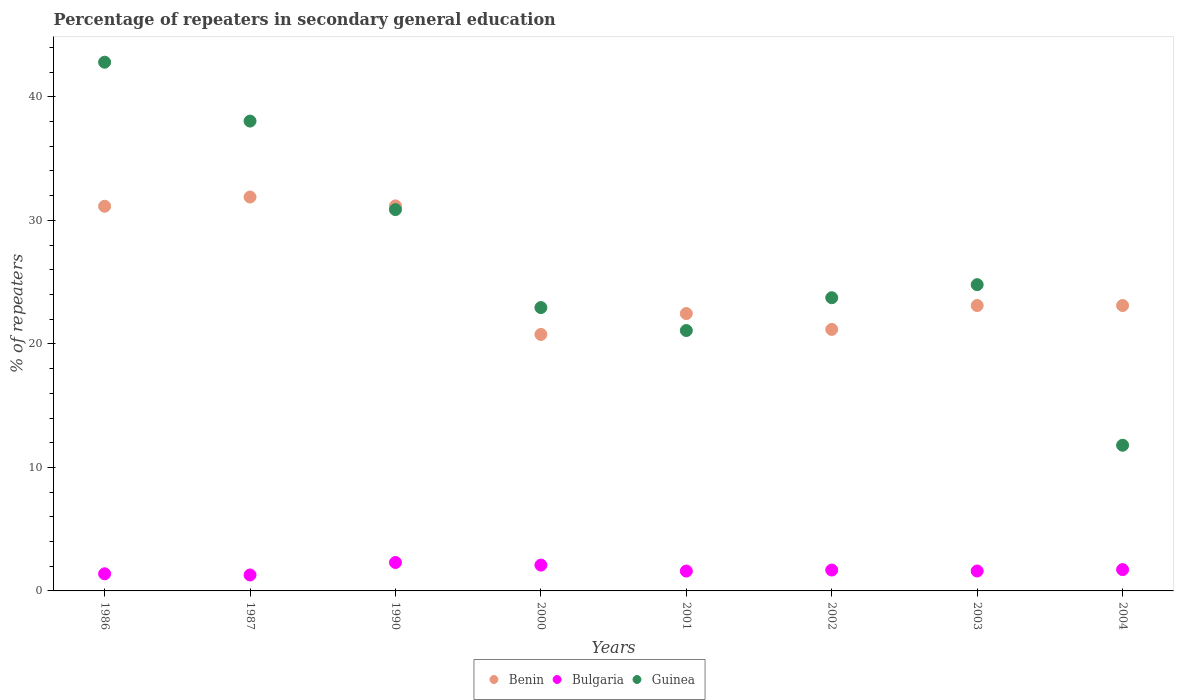How many different coloured dotlines are there?
Provide a succinct answer. 3. What is the percentage of repeaters in secondary general education in Guinea in 1987?
Make the answer very short. 38.04. Across all years, what is the maximum percentage of repeaters in secondary general education in Guinea?
Offer a terse response. 42.81. Across all years, what is the minimum percentage of repeaters in secondary general education in Guinea?
Provide a succinct answer. 11.79. In which year was the percentage of repeaters in secondary general education in Guinea maximum?
Ensure brevity in your answer.  1986. What is the total percentage of repeaters in secondary general education in Benin in the graph?
Your response must be concise. 204.82. What is the difference between the percentage of repeaters in secondary general education in Bulgaria in 1987 and that in 2001?
Provide a short and direct response. -0.32. What is the difference between the percentage of repeaters in secondary general education in Bulgaria in 1990 and the percentage of repeaters in secondary general education in Guinea in 1987?
Your answer should be compact. -35.74. What is the average percentage of repeaters in secondary general education in Benin per year?
Offer a terse response. 25.6. In the year 1986, what is the difference between the percentage of repeaters in secondary general education in Bulgaria and percentage of repeaters in secondary general education in Benin?
Your response must be concise. -29.76. What is the ratio of the percentage of repeaters in secondary general education in Guinea in 1986 to that in 2000?
Offer a terse response. 1.87. What is the difference between the highest and the second highest percentage of repeaters in secondary general education in Guinea?
Make the answer very short. 4.77. What is the difference between the highest and the lowest percentage of repeaters in secondary general education in Guinea?
Give a very brief answer. 31.01. In how many years, is the percentage of repeaters in secondary general education in Bulgaria greater than the average percentage of repeaters in secondary general education in Bulgaria taken over all years?
Your response must be concise. 3. Is it the case that in every year, the sum of the percentage of repeaters in secondary general education in Guinea and percentage of repeaters in secondary general education in Bulgaria  is greater than the percentage of repeaters in secondary general education in Benin?
Give a very brief answer. No. Does the percentage of repeaters in secondary general education in Guinea monotonically increase over the years?
Ensure brevity in your answer.  No. How many dotlines are there?
Your response must be concise. 3. What is the difference between two consecutive major ticks on the Y-axis?
Give a very brief answer. 10. Are the values on the major ticks of Y-axis written in scientific E-notation?
Make the answer very short. No. Does the graph contain any zero values?
Make the answer very short. No. Does the graph contain grids?
Offer a terse response. No. What is the title of the graph?
Keep it short and to the point. Percentage of repeaters in secondary general education. Does "Brunei Darussalam" appear as one of the legend labels in the graph?
Your answer should be compact. No. What is the label or title of the Y-axis?
Your answer should be very brief. % of repeaters. What is the % of repeaters of Benin in 1986?
Keep it short and to the point. 31.14. What is the % of repeaters of Bulgaria in 1986?
Your response must be concise. 1.39. What is the % of repeaters of Guinea in 1986?
Make the answer very short. 42.81. What is the % of repeaters in Benin in 1987?
Keep it short and to the point. 31.89. What is the % of repeaters in Bulgaria in 1987?
Offer a terse response. 1.29. What is the % of repeaters of Guinea in 1987?
Your answer should be compact. 38.04. What is the % of repeaters of Benin in 1990?
Your answer should be very brief. 31.17. What is the % of repeaters of Bulgaria in 1990?
Ensure brevity in your answer.  2.3. What is the % of repeaters in Guinea in 1990?
Provide a succinct answer. 30.87. What is the % of repeaters of Benin in 2000?
Offer a very short reply. 20.77. What is the % of repeaters of Bulgaria in 2000?
Give a very brief answer. 2.09. What is the % of repeaters of Guinea in 2000?
Your answer should be very brief. 22.94. What is the % of repeaters in Benin in 2001?
Make the answer very short. 22.46. What is the % of repeaters in Bulgaria in 2001?
Ensure brevity in your answer.  1.61. What is the % of repeaters in Guinea in 2001?
Your answer should be compact. 21.08. What is the % of repeaters of Benin in 2002?
Keep it short and to the point. 21.17. What is the % of repeaters of Bulgaria in 2002?
Provide a short and direct response. 1.69. What is the % of repeaters of Guinea in 2002?
Ensure brevity in your answer.  23.74. What is the % of repeaters in Benin in 2003?
Make the answer very short. 23.11. What is the % of repeaters of Bulgaria in 2003?
Ensure brevity in your answer.  1.61. What is the % of repeaters of Guinea in 2003?
Offer a very short reply. 24.8. What is the % of repeaters of Benin in 2004?
Provide a short and direct response. 23.11. What is the % of repeaters of Bulgaria in 2004?
Provide a short and direct response. 1.72. What is the % of repeaters in Guinea in 2004?
Offer a terse response. 11.79. Across all years, what is the maximum % of repeaters of Benin?
Your answer should be compact. 31.89. Across all years, what is the maximum % of repeaters of Bulgaria?
Provide a succinct answer. 2.3. Across all years, what is the maximum % of repeaters in Guinea?
Give a very brief answer. 42.81. Across all years, what is the minimum % of repeaters of Benin?
Your answer should be very brief. 20.77. Across all years, what is the minimum % of repeaters of Bulgaria?
Give a very brief answer. 1.29. Across all years, what is the minimum % of repeaters in Guinea?
Offer a very short reply. 11.79. What is the total % of repeaters of Benin in the graph?
Make the answer very short. 204.82. What is the total % of repeaters in Bulgaria in the graph?
Offer a very short reply. 13.7. What is the total % of repeaters of Guinea in the graph?
Offer a terse response. 216.07. What is the difference between the % of repeaters of Benin in 1986 and that in 1987?
Make the answer very short. -0.75. What is the difference between the % of repeaters of Bulgaria in 1986 and that in 1987?
Keep it short and to the point. 0.1. What is the difference between the % of repeaters of Guinea in 1986 and that in 1987?
Your answer should be very brief. 4.77. What is the difference between the % of repeaters of Benin in 1986 and that in 1990?
Offer a terse response. -0.03. What is the difference between the % of repeaters of Bulgaria in 1986 and that in 1990?
Ensure brevity in your answer.  -0.91. What is the difference between the % of repeaters in Guinea in 1986 and that in 1990?
Offer a terse response. 11.94. What is the difference between the % of repeaters of Benin in 1986 and that in 2000?
Your response must be concise. 10.38. What is the difference between the % of repeaters of Bulgaria in 1986 and that in 2000?
Keep it short and to the point. -0.7. What is the difference between the % of repeaters in Guinea in 1986 and that in 2000?
Offer a very short reply. 19.87. What is the difference between the % of repeaters of Benin in 1986 and that in 2001?
Your answer should be very brief. 8.69. What is the difference between the % of repeaters in Bulgaria in 1986 and that in 2001?
Ensure brevity in your answer.  -0.22. What is the difference between the % of repeaters of Guinea in 1986 and that in 2001?
Your response must be concise. 21.72. What is the difference between the % of repeaters in Benin in 1986 and that in 2002?
Your response must be concise. 9.97. What is the difference between the % of repeaters of Bulgaria in 1986 and that in 2002?
Your response must be concise. -0.3. What is the difference between the % of repeaters in Guinea in 1986 and that in 2002?
Offer a very short reply. 19.07. What is the difference between the % of repeaters of Benin in 1986 and that in 2003?
Your answer should be very brief. 8.04. What is the difference between the % of repeaters of Bulgaria in 1986 and that in 2003?
Make the answer very short. -0.23. What is the difference between the % of repeaters in Guinea in 1986 and that in 2003?
Ensure brevity in your answer.  18.01. What is the difference between the % of repeaters in Benin in 1986 and that in 2004?
Keep it short and to the point. 8.04. What is the difference between the % of repeaters of Bulgaria in 1986 and that in 2004?
Your response must be concise. -0.34. What is the difference between the % of repeaters in Guinea in 1986 and that in 2004?
Provide a succinct answer. 31.01. What is the difference between the % of repeaters in Benin in 1987 and that in 1990?
Your answer should be very brief. 0.72. What is the difference between the % of repeaters in Bulgaria in 1987 and that in 1990?
Give a very brief answer. -1.01. What is the difference between the % of repeaters of Guinea in 1987 and that in 1990?
Make the answer very short. 7.17. What is the difference between the % of repeaters of Benin in 1987 and that in 2000?
Your response must be concise. 11.13. What is the difference between the % of repeaters of Bulgaria in 1987 and that in 2000?
Make the answer very short. -0.8. What is the difference between the % of repeaters in Guinea in 1987 and that in 2000?
Make the answer very short. 15.1. What is the difference between the % of repeaters of Benin in 1987 and that in 2001?
Ensure brevity in your answer.  9.43. What is the difference between the % of repeaters in Bulgaria in 1987 and that in 2001?
Provide a succinct answer. -0.32. What is the difference between the % of repeaters in Guinea in 1987 and that in 2001?
Provide a short and direct response. 16.96. What is the difference between the % of repeaters of Benin in 1987 and that in 2002?
Your answer should be compact. 10.72. What is the difference between the % of repeaters of Bulgaria in 1987 and that in 2002?
Provide a short and direct response. -0.4. What is the difference between the % of repeaters in Guinea in 1987 and that in 2002?
Provide a succinct answer. 14.3. What is the difference between the % of repeaters in Benin in 1987 and that in 2003?
Make the answer very short. 8.78. What is the difference between the % of repeaters of Bulgaria in 1987 and that in 2003?
Your answer should be compact. -0.32. What is the difference between the % of repeaters in Guinea in 1987 and that in 2003?
Your response must be concise. 13.24. What is the difference between the % of repeaters of Benin in 1987 and that in 2004?
Offer a very short reply. 8.78. What is the difference between the % of repeaters of Bulgaria in 1987 and that in 2004?
Give a very brief answer. -0.43. What is the difference between the % of repeaters in Guinea in 1987 and that in 2004?
Ensure brevity in your answer.  26.25. What is the difference between the % of repeaters in Benin in 1990 and that in 2000?
Give a very brief answer. 10.41. What is the difference between the % of repeaters of Bulgaria in 1990 and that in 2000?
Your response must be concise. 0.21. What is the difference between the % of repeaters in Guinea in 1990 and that in 2000?
Your answer should be compact. 7.93. What is the difference between the % of repeaters of Benin in 1990 and that in 2001?
Offer a very short reply. 8.72. What is the difference between the % of repeaters of Bulgaria in 1990 and that in 2001?
Offer a very short reply. 0.69. What is the difference between the % of repeaters of Guinea in 1990 and that in 2001?
Ensure brevity in your answer.  9.79. What is the difference between the % of repeaters in Benin in 1990 and that in 2002?
Provide a short and direct response. 10. What is the difference between the % of repeaters of Bulgaria in 1990 and that in 2002?
Give a very brief answer. 0.61. What is the difference between the % of repeaters of Guinea in 1990 and that in 2002?
Make the answer very short. 7.13. What is the difference between the % of repeaters in Benin in 1990 and that in 2003?
Provide a short and direct response. 8.07. What is the difference between the % of repeaters of Bulgaria in 1990 and that in 2003?
Give a very brief answer. 0.69. What is the difference between the % of repeaters in Guinea in 1990 and that in 2003?
Your answer should be compact. 6.08. What is the difference between the % of repeaters in Benin in 1990 and that in 2004?
Offer a terse response. 8.07. What is the difference between the % of repeaters of Bulgaria in 1990 and that in 2004?
Offer a very short reply. 0.58. What is the difference between the % of repeaters of Guinea in 1990 and that in 2004?
Ensure brevity in your answer.  19.08. What is the difference between the % of repeaters of Benin in 2000 and that in 2001?
Ensure brevity in your answer.  -1.69. What is the difference between the % of repeaters in Bulgaria in 2000 and that in 2001?
Your answer should be very brief. 0.48. What is the difference between the % of repeaters in Guinea in 2000 and that in 2001?
Ensure brevity in your answer.  1.86. What is the difference between the % of repeaters of Benin in 2000 and that in 2002?
Provide a succinct answer. -0.41. What is the difference between the % of repeaters of Bulgaria in 2000 and that in 2002?
Offer a terse response. 0.4. What is the difference between the % of repeaters of Guinea in 2000 and that in 2002?
Ensure brevity in your answer.  -0.8. What is the difference between the % of repeaters of Benin in 2000 and that in 2003?
Provide a short and direct response. -2.34. What is the difference between the % of repeaters of Bulgaria in 2000 and that in 2003?
Your response must be concise. 0.48. What is the difference between the % of repeaters in Guinea in 2000 and that in 2003?
Your answer should be very brief. -1.85. What is the difference between the % of repeaters in Benin in 2000 and that in 2004?
Provide a short and direct response. -2.34. What is the difference between the % of repeaters in Bulgaria in 2000 and that in 2004?
Offer a terse response. 0.37. What is the difference between the % of repeaters in Guinea in 2000 and that in 2004?
Give a very brief answer. 11.15. What is the difference between the % of repeaters in Benin in 2001 and that in 2002?
Offer a terse response. 1.29. What is the difference between the % of repeaters of Bulgaria in 2001 and that in 2002?
Make the answer very short. -0.08. What is the difference between the % of repeaters of Guinea in 2001 and that in 2002?
Provide a short and direct response. -2.66. What is the difference between the % of repeaters in Benin in 2001 and that in 2003?
Offer a very short reply. -0.65. What is the difference between the % of repeaters of Bulgaria in 2001 and that in 2003?
Provide a short and direct response. -0. What is the difference between the % of repeaters of Guinea in 2001 and that in 2003?
Give a very brief answer. -3.71. What is the difference between the % of repeaters of Benin in 2001 and that in 2004?
Offer a very short reply. -0.65. What is the difference between the % of repeaters of Bulgaria in 2001 and that in 2004?
Give a very brief answer. -0.12. What is the difference between the % of repeaters in Guinea in 2001 and that in 2004?
Your response must be concise. 9.29. What is the difference between the % of repeaters in Benin in 2002 and that in 2003?
Your response must be concise. -1.94. What is the difference between the % of repeaters of Bulgaria in 2002 and that in 2003?
Provide a succinct answer. 0.08. What is the difference between the % of repeaters of Guinea in 2002 and that in 2003?
Offer a very short reply. -1.06. What is the difference between the % of repeaters of Benin in 2002 and that in 2004?
Make the answer very short. -1.94. What is the difference between the % of repeaters of Bulgaria in 2002 and that in 2004?
Provide a short and direct response. -0.03. What is the difference between the % of repeaters of Guinea in 2002 and that in 2004?
Keep it short and to the point. 11.94. What is the difference between the % of repeaters of Benin in 2003 and that in 2004?
Offer a terse response. -0. What is the difference between the % of repeaters of Bulgaria in 2003 and that in 2004?
Offer a very short reply. -0.11. What is the difference between the % of repeaters of Guinea in 2003 and that in 2004?
Make the answer very short. 13. What is the difference between the % of repeaters of Benin in 1986 and the % of repeaters of Bulgaria in 1987?
Provide a succinct answer. 29.85. What is the difference between the % of repeaters in Benin in 1986 and the % of repeaters in Guinea in 1987?
Offer a very short reply. -6.9. What is the difference between the % of repeaters in Bulgaria in 1986 and the % of repeaters in Guinea in 1987?
Offer a terse response. -36.65. What is the difference between the % of repeaters of Benin in 1986 and the % of repeaters of Bulgaria in 1990?
Your answer should be compact. 28.84. What is the difference between the % of repeaters in Benin in 1986 and the % of repeaters in Guinea in 1990?
Offer a very short reply. 0.27. What is the difference between the % of repeaters in Bulgaria in 1986 and the % of repeaters in Guinea in 1990?
Your answer should be very brief. -29.48. What is the difference between the % of repeaters of Benin in 1986 and the % of repeaters of Bulgaria in 2000?
Your answer should be very brief. 29.05. What is the difference between the % of repeaters of Benin in 1986 and the % of repeaters of Guinea in 2000?
Provide a succinct answer. 8.2. What is the difference between the % of repeaters of Bulgaria in 1986 and the % of repeaters of Guinea in 2000?
Give a very brief answer. -21.55. What is the difference between the % of repeaters in Benin in 1986 and the % of repeaters in Bulgaria in 2001?
Make the answer very short. 29.54. What is the difference between the % of repeaters in Benin in 1986 and the % of repeaters in Guinea in 2001?
Offer a very short reply. 10.06. What is the difference between the % of repeaters in Bulgaria in 1986 and the % of repeaters in Guinea in 2001?
Your response must be concise. -19.7. What is the difference between the % of repeaters in Benin in 1986 and the % of repeaters in Bulgaria in 2002?
Keep it short and to the point. 29.45. What is the difference between the % of repeaters of Benin in 1986 and the % of repeaters of Guinea in 2002?
Make the answer very short. 7.4. What is the difference between the % of repeaters of Bulgaria in 1986 and the % of repeaters of Guinea in 2002?
Your response must be concise. -22.35. What is the difference between the % of repeaters in Benin in 1986 and the % of repeaters in Bulgaria in 2003?
Your response must be concise. 29.53. What is the difference between the % of repeaters of Benin in 1986 and the % of repeaters of Guinea in 2003?
Provide a short and direct response. 6.35. What is the difference between the % of repeaters in Bulgaria in 1986 and the % of repeaters in Guinea in 2003?
Your response must be concise. -23.41. What is the difference between the % of repeaters in Benin in 1986 and the % of repeaters in Bulgaria in 2004?
Your answer should be very brief. 29.42. What is the difference between the % of repeaters in Benin in 1986 and the % of repeaters in Guinea in 2004?
Offer a terse response. 19.35. What is the difference between the % of repeaters of Bulgaria in 1986 and the % of repeaters of Guinea in 2004?
Make the answer very short. -10.41. What is the difference between the % of repeaters of Benin in 1987 and the % of repeaters of Bulgaria in 1990?
Provide a short and direct response. 29.59. What is the difference between the % of repeaters of Benin in 1987 and the % of repeaters of Guinea in 1990?
Keep it short and to the point. 1.02. What is the difference between the % of repeaters of Bulgaria in 1987 and the % of repeaters of Guinea in 1990?
Your answer should be compact. -29.58. What is the difference between the % of repeaters of Benin in 1987 and the % of repeaters of Bulgaria in 2000?
Your answer should be compact. 29.8. What is the difference between the % of repeaters of Benin in 1987 and the % of repeaters of Guinea in 2000?
Ensure brevity in your answer.  8.95. What is the difference between the % of repeaters in Bulgaria in 1987 and the % of repeaters in Guinea in 2000?
Provide a short and direct response. -21.65. What is the difference between the % of repeaters in Benin in 1987 and the % of repeaters in Bulgaria in 2001?
Your response must be concise. 30.28. What is the difference between the % of repeaters of Benin in 1987 and the % of repeaters of Guinea in 2001?
Provide a succinct answer. 10.81. What is the difference between the % of repeaters of Bulgaria in 1987 and the % of repeaters of Guinea in 2001?
Offer a terse response. -19.79. What is the difference between the % of repeaters in Benin in 1987 and the % of repeaters in Bulgaria in 2002?
Your answer should be compact. 30.2. What is the difference between the % of repeaters of Benin in 1987 and the % of repeaters of Guinea in 2002?
Your response must be concise. 8.15. What is the difference between the % of repeaters in Bulgaria in 1987 and the % of repeaters in Guinea in 2002?
Your response must be concise. -22.45. What is the difference between the % of repeaters in Benin in 1987 and the % of repeaters in Bulgaria in 2003?
Ensure brevity in your answer.  30.28. What is the difference between the % of repeaters in Benin in 1987 and the % of repeaters in Guinea in 2003?
Make the answer very short. 7.1. What is the difference between the % of repeaters in Bulgaria in 1987 and the % of repeaters in Guinea in 2003?
Make the answer very short. -23.51. What is the difference between the % of repeaters of Benin in 1987 and the % of repeaters of Bulgaria in 2004?
Your answer should be very brief. 30.17. What is the difference between the % of repeaters in Benin in 1987 and the % of repeaters in Guinea in 2004?
Your response must be concise. 20.1. What is the difference between the % of repeaters of Bulgaria in 1987 and the % of repeaters of Guinea in 2004?
Offer a terse response. -10.5. What is the difference between the % of repeaters in Benin in 1990 and the % of repeaters in Bulgaria in 2000?
Give a very brief answer. 29.08. What is the difference between the % of repeaters of Benin in 1990 and the % of repeaters of Guinea in 2000?
Your answer should be very brief. 8.23. What is the difference between the % of repeaters in Bulgaria in 1990 and the % of repeaters in Guinea in 2000?
Offer a terse response. -20.64. What is the difference between the % of repeaters in Benin in 1990 and the % of repeaters in Bulgaria in 2001?
Provide a short and direct response. 29.57. What is the difference between the % of repeaters of Benin in 1990 and the % of repeaters of Guinea in 2001?
Ensure brevity in your answer.  10.09. What is the difference between the % of repeaters in Bulgaria in 1990 and the % of repeaters in Guinea in 2001?
Give a very brief answer. -18.78. What is the difference between the % of repeaters in Benin in 1990 and the % of repeaters in Bulgaria in 2002?
Your response must be concise. 29.48. What is the difference between the % of repeaters in Benin in 1990 and the % of repeaters in Guinea in 2002?
Your answer should be compact. 7.44. What is the difference between the % of repeaters of Bulgaria in 1990 and the % of repeaters of Guinea in 2002?
Keep it short and to the point. -21.44. What is the difference between the % of repeaters of Benin in 1990 and the % of repeaters of Bulgaria in 2003?
Give a very brief answer. 29.56. What is the difference between the % of repeaters in Benin in 1990 and the % of repeaters in Guinea in 2003?
Provide a succinct answer. 6.38. What is the difference between the % of repeaters of Bulgaria in 1990 and the % of repeaters of Guinea in 2003?
Your answer should be very brief. -22.5. What is the difference between the % of repeaters in Benin in 1990 and the % of repeaters in Bulgaria in 2004?
Your response must be concise. 29.45. What is the difference between the % of repeaters of Benin in 1990 and the % of repeaters of Guinea in 2004?
Provide a succinct answer. 19.38. What is the difference between the % of repeaters in Bulgaria in 1990 and the % of repeaters in Guinea in 2004?
Give a very brief answer. -9.49. What is the difference between the % of repeaters in Benin in 2000 and the % of repeaters in Bulgaria in 2001?
Provide a short and direct response. 19.16. What is the difference between the % of repeaters in Benin in 2000 and the % of repeaters in Guinea in 2001?
Make the answer very short. -0.32. What is the difference between the % of repeaters of Bulgaria in 2000 and the % of repeaters of Guinea in 2001?
Your answer should be very brief. -18.99. What is the difference between the % of repeaters of Benin in 2000 and the % of repeaters of Bulgaria in 2002?
Make the answer very short. 19.08. What is the difference between the % of repeaters in Benin in 2000 and the % of repeaters in Guinea in 2002?
Provide a short and direct response. -2.97. What is the difference between the % of repeaters of Bulgaria in 2000 and the % of repeaters of Guinea in 2002?
Offer a terse response. -21.65. What is the difference between the % of repeaters of Benin in 2000 and the % of repeaters of Bulgaria in 2003?
Give a very brief answer. 19.15. What is the difference between the % of repeaters in Benin in 2000 and the % of repeaters in Guinea in 2003?
Keep it short and to the point. -4.03. What is the difference between the % of repeaters in Bulgaria in 2000 and the % of repeaters in Guinea in 2003?
Offer a very short reply. -22.71. What is the difference between the % of repeaters of Benin in 2000 and the % of repeaters of Bulgaria in 2004?
Give a very brief answer. 19.04. What is the difference between the % of repeaters in Benin in 2000 and the % of repeaters in Guinea in 2004?
Provide a succinct answer. 8.97. What is the difference between the % of repeaters in Bulgaria in 2000 and the % of repeaters in Guinea in 2004?
Your answer should be compact. -9.7. What is the difference between the % of repeaters of Benin in 2001 and the % of repeaters of Bulgaria in 2002?
Provide a short and direct response. 20.77. What is the difference between the % of repeaters in Benin in 2001 and the % of repeaters in Guinea in 2002?
Make the answer very short. -1.28. What is the difference between the % of repeaters of Bulgaria in 2001 and the % of repeaters of Guinea in 2002?
Your answer should be compact. -22.13. What is the difference between the % of repeaters of Benin in 2001 and the % of repeaters of Bulgaria in 2003?
Your answer should be very brief. 20.84. What is the difference between the % of repeaters in Benin in 2001 and the % of repeaters in Guinea in 2003?
Give a very brief answer. -2.34. What is the difference between the % of repeaters of Bulgaria in 2001 and the % of repeaters of Guinea in 2003?
Keep it short and to the point. -23.19. What is the difference between the % of repeaters of Benin in 2001 and the % of repeaters of Bulgaria in 2004?
Give a very brief answer. 20.73. What is the difference between the % of repeaters in Benin in 2001 and the % of repeaters in Guinea in 2004?
Give a very brief answer. 10.66. What is the difference between the % of repeaters in Bulgaria in 2001 and the % of repeaters in Guinea in 2004?
Give a very brief answer. -10.19. What is the difference between the % of repeaters of Benin in 2002 and the % of repeaters of Bulgaria in 2003?
Your answer should be very brief. 19.56. What is the difference between the % of repeaters in Benin in 2002 and the % of repeaters in Guinea in 2003?
Keep it short and to the point. -3.62. What is the difference between the % of repeaters in Bulgaria in 2002 and the % of repeaters in Guinea in 2003?
Keep it short and to the point. -23.11. What is the difference between the % of repeaters in Benin in 2002 and the % of repeaters in Bulgaria in 2004?
Offer a very short reply. 19.45. What is the difference between the % of repeaters of Benin in 2002 and the % of repeaters of Guinea in 2004?
Your answer should be compact. 9.38. What is the difference between the % of repeaters of Bulgaria in 2002 and the % of repeaters of Guinea in 2004?
Your answer should be very brief. -10.1. What is the difference between the % of repeaters in Benin in 2003 and the % of repeaters in Bulgaria in 2004?
Keep it short and to the point. 21.38. What is the difference between the % of repeaters of Benin in 2003 and the % of repeaters of Guinea in 2004?
Make the answer very short. 11.31. What is the difference between the % of repeaters in Bulgaria in 2003 and the % of repeaters in Guinea in 2004?
Your answer should be compact. -10.18. What is the average % of repeaters of Benin per year?
Offer a terse response. 25.6. What is the average % of repeaters in Bulgaria per year?
Offer a very short reply. 1.71. What is the average % of repeaters in Guinea per year?
Provide a short and direct response. 27.01. In the year 1986, what is the difference between the % of repeaters in Benin and % of repeaters in Bulgaria?
Give a very brief answer. 29.76. In the year 1986, what is the difference between the % of repeaters of Benin and % of repeaters of Guinea?
Make the answer very short. -11.66. In the year 1986, what is the difference between the % of repeaters of Bulgaria and % of repeaters of Guinea?
Offer a terse response. -41.42. In the year 1987, what is the difference between the % of repeaters in Benin and % of repeaters in Bulgaria?
Offer a terse response. 30.6. In the year 1987, what is the difference between the % of repeaters in Benin and % of repeaters in Guinea?
Ensure brevity in your answer.  -6.15. In the year 1987, what is the difference between the % of repeaters of Bulgaria and % of repeaters of Guinea?
Offer a terse response. -36.75. In the year 1990, what is the difference between the % of repeaters in Benin and % of repeaters in Bulgaria?
Your answer should be very brief. 28.87. In the year 1990, what is the difference between the % of repeaters of Benin and % of repeaters of Guinea?
Provide a succinct answer. 0.3. In the year 1990, what is the difference between the % of repeaters of Bulgaria and % of repeaters of Guinea?
Give a very brief answer. -28.57. In the year 2000, what is the difference between the % of repeaters in Benin and % of repeaters in Bulgaria?
Keep it short and to the point. 18.68. In the year 2000, what is the difference between the % of repeaters of Benin and % of repeaters of Guinea?
Your response must be concise. -2.18. In the year 2000, what is the difference between the % of repeaters in Bulgaria and % of repeaters in Guinea?
Provide a short and direct response. -20.85. In the year 2001, what is the difference between the % of repeaters of Benin and % of repeaters of Bulgaria?
Give a very brief answer. 20.85. In the year 2001, what is the difference between the % of repeaters in Benin and % of repeaters in Guinea?
Ensure brevity in your answer.  1.37. In the year 2001, what is the difference between the % of repeaters of Bulgaria and % of repeaters of Guinea?
Provide a short and direct response. -19.48. In the year 2002, what is the difference between the % of repeaters in Benin and % of repeaters in Bulgaria?
Your answer should be very brief. 19.48. In the year 2002, what is the difference between the % of repeaters in Benin and % of repeaters in Guinea?
Keep it short and to the point. -2.57. In the year 2002, what is the difference between the % of repeaters of Bulgaria and % of repeaters of Guinea?
Give a very brief answer. -22.05. In the year 2003, what is the difference between the % of repeaters in Benin and % of repeaters in Bulgaria?
Your response must be concise. 21.5. In the year 2003, what is the difference between the % of repeaters of Benin and % of repeaters of Guinea?
Your answer should be very brief. -1.69. In the year 2003, what is the difference between the % of repeaters of Bulgaria and % of repeaters of Guinea?
Ensure brevity in your answer.  -23.18. In the year 2004, what is the difference between the % of repeaters of Benin and % of repeaters of Bulgaria?
Make the answer very short. 21.38. In the year 2004, what is the difference between the % of repeaters in Benin and % of repeaters in Guinea?
Make the answer very short. 11.31. In the year 2004, what is the difference between the % of repeaters in Bulgaria and % of repeaters in Guinea?
Give a very brief answer. -10.07. What is the ratio of the % of repeaters in Benin in 1986 to that in 1987?
Your answer should be compact. 0.98. What is the ratio of the % of repeaters in Bulgaria in 1986 to that in 1987?
Keep it short and to the point. 1.07. What is the ratio of the % of repeaters of Guinea in 1986 to that in 1987?
Your answer should be compact. 1.13. What is the ratio of the % of repeaters in Bulgaria in 1986 to that in 1990?
Your answer should be compact. 0.6. What is the ratio of the % of repeaters of Guinea in 1986 to that in 1990?
Your answer should be very brief. 1.39. What is the ratio of the % of repeaters in Benin in 1986 to that in 2000?
Your response must be concise. 1.5. What is the ratio of the % of repeaters in Bulgaria in 1986 to that in 2000?
Ensure brevity in your answer.  0.66. What is the ratio of the % of repeaters in Guinea in 1986 to that in 2000?
Offer a very short reply. 1.87. What is the ratio of the % of repeaters of Benin in 1986 to that in 2001?
Make the answer very short. 1.39. What is the ratio of the % of repeaters in Bulgaria in 1986 to that in 2001?
Provide a short and direct response. 0.86. What is the ratio of the % of repeaters in Guinea in 1986 to that in 2001?
Your answer should be compact. 2.03. What is the ratio of the % of repeaters of Benin in 1986 to that in 2002?
Offer a terse response. 1.47. What is the ratio of the % of repeaters of Bulgaria in 1986 to that in 2002?
Your response must be concise. 0.82. What is the ratio of the % of repeaters in Guinea in 1986 to that in 2002?
Offer a terse response. 1.8. What is the ratio of the % of repeaters in Benin in 1986 to that in 2003?
Your response must be concise. 1.35. What is the ratio of the % of repeaters in Bulgaria in 1986 to that in 2003?
Your answer should be compact. 0.86. What is the ratio of the % of repeaters of Guinea in 1986 to that in 2003?
Your answer should be compact. 1.73. What is the ratio of the % of repeaters of Benin in 1986 to that in 2004?
Offer a terse response. 1.35. What is the ratio of the % of repeaters of Bulgaria in 1986 to that in 2004?
Make the answer very short. 0.8. What is the ratio of the % of repeaters of Guinea in 1986 to that in 2004?
Keep it short and to the point. 3.63. What is the ratio of the % of repeaters in Benin in 1987 to that in 1990?
Give a very brief answer. 1.02. What is the ratio of the % of repeaters of Bulgaria in 1987 to that in 1990?
Provide a succinct answer. 0.56. What is the ratio of the % of repeaters in Guinea in 1987 to that in 1990?
Your answer should be very brief. 1.23. What is the ratio of the % of repeaters in Benin in 1987 to that in 2000?
Make the answer very short. 1.54. What is the ratio of the % of repeaters of Bulgaria in 1987 to that in 2000?
Make the answer very short. 0.62. What is the ratio of the % of repeaters in Guinea in 1987 to that in 2000?
Keep it short and to the point. 1.66. What is the ratio of the % of repeaters of Benin in 1987 to that in 2001?
Keep it short and to the point. 1.42. What is the ratio of the % of repeaters in Bulgaria in 1987 to that in 2001?
Give a very brief answer. 0.8. What is the ratio of the % of repeaters in Guinea in 1987 to that in 2001?
Give a very brief answer. 1.8. What is the ratio of the % of repeaters of Benin in 1987 to that in 2002?
Offer a terse response. 1.51. What is the ratio of the % of repeaters of Bulgaria in 1987 to that in 2002?
Ensure brevity in your answer.  0.76. What is the ratio of the % of repeaters of Guinea in 1987 to that in 2002?
Make the answer very short. 1.6. What is the ratio of the % of repeaters of Benin in 1987 to that in 2003?
Keep it short and to the point. 1.38. What is the ratio of the % of repeaters of Bulgaria in 1987 to that in 2003?
Keep it short and to the point. 0.8. What is the ratio of the % of repeaters in Guinea in 1987 to that in 2003?
Your answer should be compact. 1.53. What is the ratio of the % of repeaters in Benin in 1987 to that in 2004?
Your response must be concise. 1.38. What is the ratio of the % of repeaters in Bulgaria in 1987 to that in 2004?
Offer a very short reply. 0.75. What is the ratio of the % of repeaters in Guinea in 1987 to that in 2004?
Make the answer very short. 3.23. What is the ratio of the % of repeaters of Benin in 1990 to that in 2000?
Make the answer very short. 1.5. What is the ratio of the % of repeaters of Bulgaria in 1990 to that in 2000?
Make the answer very short. 1.1. What is the ratio of the % of repeaters of Guinea in 1990 to that in 2000?
Give a very brief answer. 1.35. What is the ratio of the % of repeaters in Benin in 1990 to that in 2001?
Keep it short and to the point. 1.39. What is the ratio of the % of repeaters in Bulgaria in 1990 to that in 2001?
Provide a short and direct response. 1.43. What is the ratio of the % of repeaters of Guinea in 1990 to that in 2001?
Your answer should be compact. 1.46. What is the ratio of the % of repeaters in Benin in 1990 to that in 2002?
Make the answer very short. 1.47. What is the ratio of the % of repeaters of Bulgaria in 1990 to that in 2002?
Give a very brief answer. 1.36. What is the ratio of the % of repeaters of Guinea in 1990 to that in 2002?
Provide a succinct answer. 1.3. What is the ratio of the % of repeaters of Benin in 1990 to that in 2003?
Your answer should be very brief. 1.35. What is the ratio of the % of repeaters of Bulgaria in 1990 to that in 2003?
Your answer should be very brief. 1.43. What is the ratio of the % of repeaters in Guinea in 1990 to that in 2003?
Your response must be concise. 1.25. What is the ratio of the % of repeaters of Benin in 1990 to that in 2004?
Provide a short and direct response. 1.35. What is the ratio of the % of repeaters in Bulgaria in 1990 to that in 2004?
Give a very brief answer. 1.33. What is the ratio of the % of repeaters in Guinea in 1990 to that in 2004?
Provide a succinct answer. 2.62. What is the ratio of the % of repeaters of Benin in 2000 to that in 2001?
Offer a terse response. 0.92. What is the ratio of the % of repeaters in Bulgaria in 2000 to that in 2001?
Give a very brief answer. 1.3. What is the ratio of the % of repeaters in Guinea in 2000 to that in 2001?
Ensure brevity in your answer.  1.09. What is the ratio of the % of repeaters of Benin in 2000 to that in 2002?
Offer a terse response. 0.98. What is the ratio of the % of repeaters in Bulgaria in 2000 to that in 2002?
Your answer should be compact. 1.24. What is the ratio of the % of repeaters in Guinea in 2000 to that in 2002?
Your response must be concise. 0.97. What is the ratio of the % of repeaters of Benin in 2000 to that in 2003?
Offer a terse response. 0.9. What is the ratio of the % of repeaters in Bulgaria in 2000 to that in 2003?
Give a very brief answer. 1.3. What is the ratio of the % of repeaters in Guinea in 2000 to that in 2003?
Your answer should be compact. 0.93. What is the ratio of the % of repeaters in Benin in 2000 to that in 2004?
Offer a terse response. 0.9. What is the ratio of the % of repeaters of Bulgaria in 2000 to that in 2004?
Your answer should be compact. 1.21. What is the ratio of the % of repeaters in Guinea in 2000 to that in 2004?
Keep it short and to the point. 1.95. What is the ratio of the % of repeaters in Benin in 2001 to that in 2002?
Your answer should be very brief. 1.06. What is the ratio of the % of repeaters in Bulgaria in 2001 to that in 2002?
Offer a terse response. 0.95. What is the ratio of the % of repeaters of Guinea in 2001 to that in 2002?
Your answer should be very brief. 0.89. What is the ratio of the % of repeaters in Benin in 2001 to that in 2003?
Offer a terse response. 0.97. What is the ratio of the % of repeaters of Guinea in 2001 to that in 2003?
Give a very brief answer. 0.85. What is the ratio of the % of repeaters of Benin in 2001 to that in 2004?
Make the answer very short. 0.97. What is the ratio of the % of repeaters in Bulgaria in 2001 to that in 2004?
Keep it short and to the point. 0.93. What is the ratio of the % of repeaters of Guinea in 2001 to that in 2004?
Make the answer very short. 1.79. What is the ratio of the % of repeaters of Benin in 2002 to that in 2003?
Offer a terse response. 0.92. What is the ratio of the % of repeaters in Bulgaria in 2002 to that in 2003?
Ensure brevity in your answer.  1.05. What is the ratio of the % of repeaters in Guinea in 2002 to that in 2003?
Give a very brief answer. 0.96. What is the ratio of the % of repeaters of Benin in 2002 to that in 2004?
Offer a terse response. 0.92. What is the ratio of the % of repeaters of Bulgaria in 2002 to that in 2004?
Offer a terse response. 0.98. What is the ratio of the % of repeaters of Guinea in 2002 to that in 2004?
Keep it short and to the point. 2.01. What is the ratio of the % of repeaters in Benin in 2003 to that in 2004?
Your answer should be compact. 1. What is the ratio of the % of repeaters of Bulgaria in 2003 to that in 2004?
Give a very brief answer. 0.93. What is the ratio of the % of repeaters in Guinea in 2003 to that in 2004?
Keep it short and to the point. 2.1. What is the difference between the highest and the second highest % of repeaters of Benin?
Make the answer very short. 0.72. What is the difference between the highest and the second highest % of repeaters in Bulgaria?
Keep it short and to the point. 0.21. What is the difference between the highest and the second highest % of repeaters of Guinea?
Keep it short and to the point. 4.77. What is the difference between the highest and the lowest % of repeaters of Benin?
Your response must be concise. 11.13. What is the difference between the highest and the lowest % of repeaters of Bulgaria?
Give a very brief answer. 1.01. What is the difference between the highest and the lowest % of repeaters in Guinea?
Offer a very short reply. 31.01. 